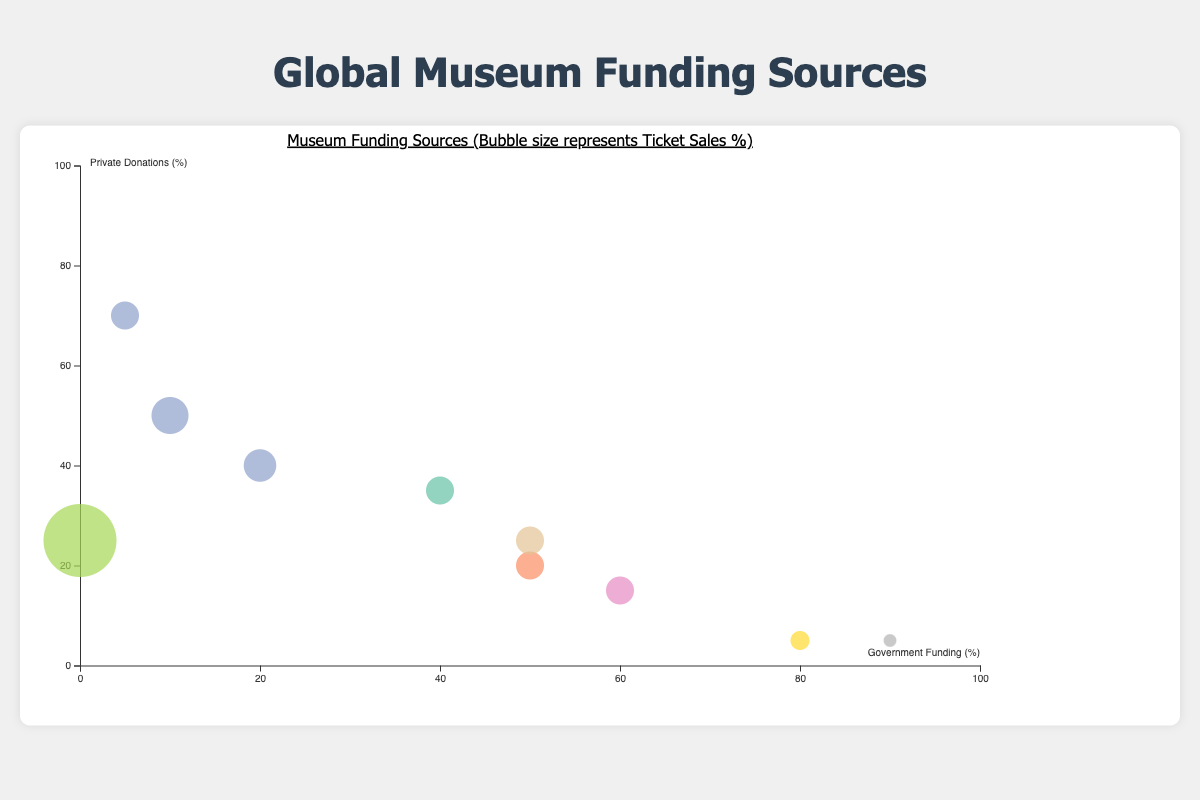What does the title of the graph say? The title is positioned at the top and states "Museum Funding Sources (Bubble size represents Ticket Sales %)". This summarizes the content and the main visual encoding strategy used in the graph.
Answer: Museum Funding Sources (Bubble size represents Ticket Sales %) What percentages are represented on the x and y axes? The x-axis represents "Government Funding (%)" and the y-axis represents "Private Donations (%)". Each axis is labeled with its respective category and a percentage sign.
Answer: Government Funding (%) and Private Donations (%) Which museum relies the most on private donations? Locate the bubble positioned highest on the y-axis (Private Donations). "The Getty Center" in the United States, which has a private donation value of 70%, is the highest.
Answer: The Getty Center Which museum has the smallest bubble size? The size of the bubbles represents "Ticket Sales (%)". The smallest bubble appears almost negligible compared to others. "The National Museum of China" has the smallest bubble, indicating only 3% of funding from ticket sales.
Answer: The National Museum of China What is the combined percentage of Government Funding and Private Donations for The Louvre? Look at the position of The Louvre bubble on both x and y axes. The Louvre has 40% Government Funding and 35% Private Donations. Combined, the total percentage is 40 + 35.
Answer: 75% How does the Government Funding of The Metropolitan Museum of Art compare to The Louvre? The Metropolitan Museum of Art has 10% Government Funding while The Louvre has 40% Government Funding. Comparing these percentages, The Louvre has a significantly higher Government Funding.
Answer: The Louvre has higher Government Funding What is the most common range for Government Funding among museums in the chart? Observing the distribution of bubbles along the x-axis, we can see that most museums fall between 10% and 60% in Government Funding.
Answer: 10% to 60% If we calculate the average percentage of Private Donations from the museums shown, what would it be? Sum up the Private Donations percentages for each museum (35 + 20 + 50 + 15 + 25 + 5 + 25 + 70 + 5 + 40 = 290), then divide by the number of museums (10). The average is 290 / 10.
Answer: 29% Which museum has the highest combination of Government Funding and Ticket Sales? Review the axes positions and bubble sizes. The combination of Government Funding (x-axis) and Ticket Sales (bubble size) is highest for The National Museum of China with 90% Government Funding and a small Ticket Sales of 3%.
Answer: The National Museum of China Do any museums have equal amounts of Government Funding and Private Donations? Compare and analyse the values on the x and y axes for any matching percentages. The British Museum has 50% Government Funding and 50% Private Donations.
Answer: No 